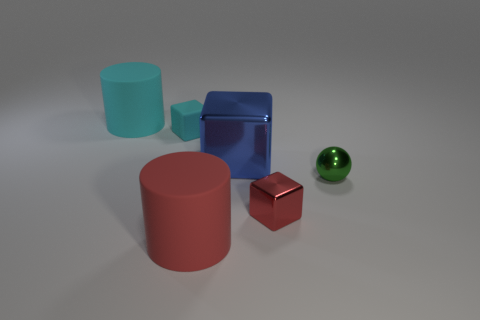Add 4 green cylinders. How many objects exist? 10 Subtract all cylinders. How many objects are left? 4 Add 4 red metallic things. How many red metallic things exist? 5 Subtract 0 brown cubes. How many objects are left? 6 Subtract all large rubber objects. Subtract all tiny cyan objects. How many objects are left? 3 Add 1 tiny cyan cubes. How many tiny cyan cubes are left? 2 